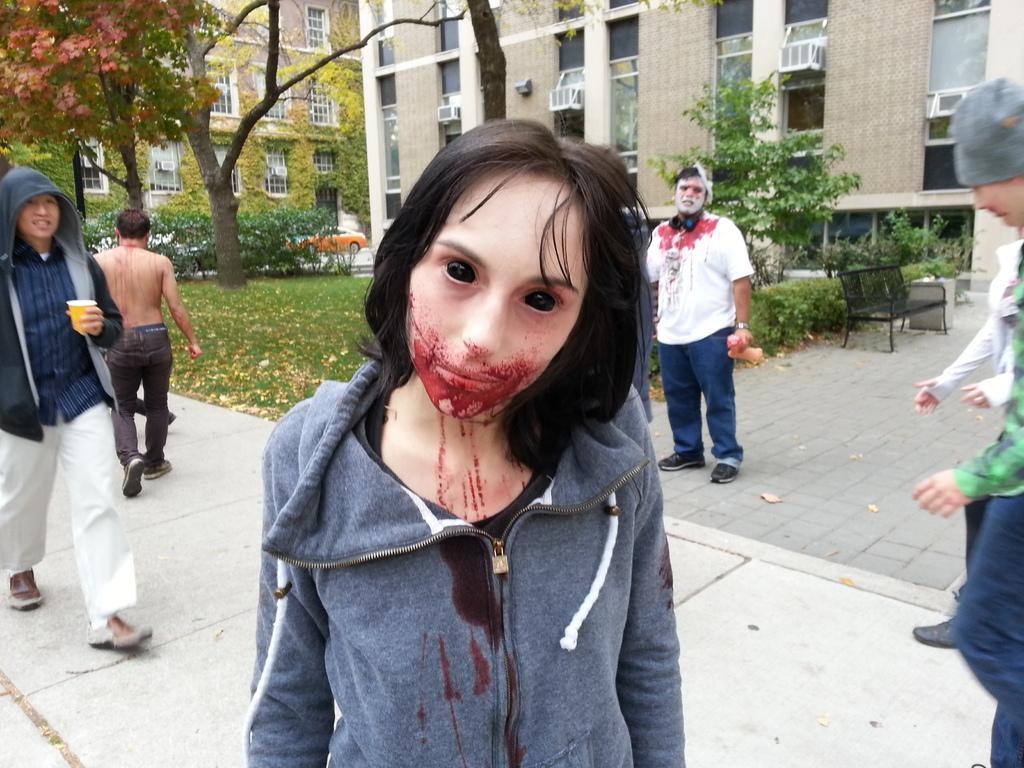Could you give a brief overview of what you see in this image? In the center of the image there is a girl wearing a jacket. In the background of the image there are buildings,trees and vehicles on the road. To the left side of the image there is a person walking on the pavement. To the right side of the image there are people. There is a bench. 